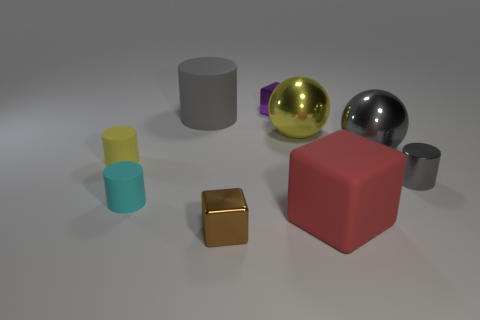Subtract all big red cubes. How many cubes are left? 2 Subtract all cyan cylinders. How many cylinders are left? 3 Subtract all blue cylinders. Subtract all yellow balls. How many cylinders are left? 4 Subtract all cubes. How many objects are left? 6 Subtract all small cyan cubes. Subtract all cylinders. How many objects are left? 5 Add 1 cyan cylinders. How many cyan cylinders are left? 2 Add 3 big gray rubber objects. How many big gray rubber objects exist? 4 Subtract 0 purple cylinders. How many objects are left? 9 